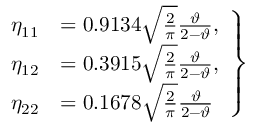Convert formula to latex. <formula><loc_0><loc_0><loc_500><loc_500>\begin{array} { r } { \begin{array} { r l } { \eta _ { 1 1 } } & { = 0 . 9 1 3 4 \sqrt { \frac { 2 } { \pi } } \frac { \vartheta } { 2 - \vartheta } , } \\ { \eta _ { 1 2 } } & { = 0 . 3 9 1 5 \sqrt { \frac { 2 } { \pi } } \frac { \vartheta } { 2 - \vartheta } , } \\ { \eta _ { 2 2 } } & { = 0 . 1 6 7 8 \sqrt { \frac { 2 } { \pi } } \frac { \vartheta } { 2 - \vartheta } } \end{array} \right \} } \end{array}</formula> 